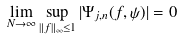Convert formula to latex. <formula><loc_0><loc_0><loc_500><loc_500>& \lim _ { N \to \infty } \sup _ { \| f \| _ { \infty } \leq 1 } | \Psi _ { j , n } ( f , \psi ) | = 0</formula> 